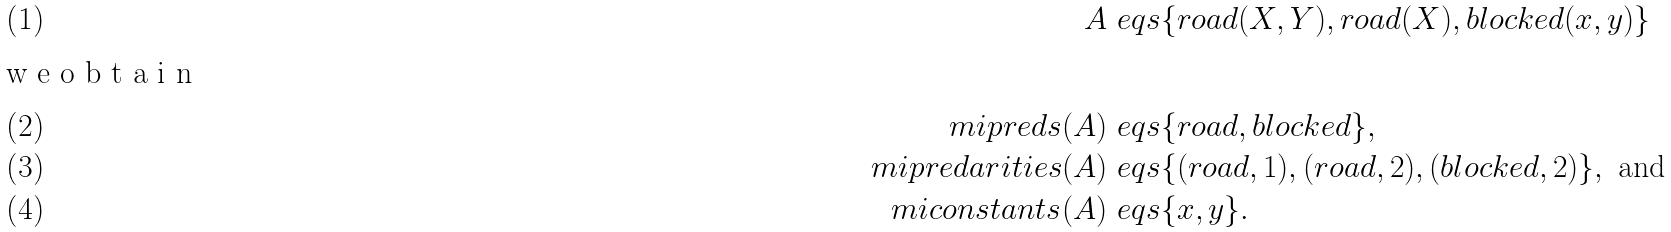Convert formula to latex. <formula><loc_0><loc_0><loc_500><loc_500>A \ e q s & \{ r o a d ( X , Y ) , r o a d ( X ) , b l o c k e d ( x , y ) \} \\ \intertext { w e o b t a i n } \ m i { p r e d s } ( A ) \ e q s & \{ r o a d , b l o c k e d \} , \\ \ m i { p r e d a r i t i e s } ( A ) \ e q s & \{ ( r o a d , 1 ) , ( r o a d , 2 ) , ( b l o c k e d , 2 ) \} , \text { and} \\ \ m i { c o n s t a n t s } ( A ) \ e q s & \{ x , y \} .</formula> 